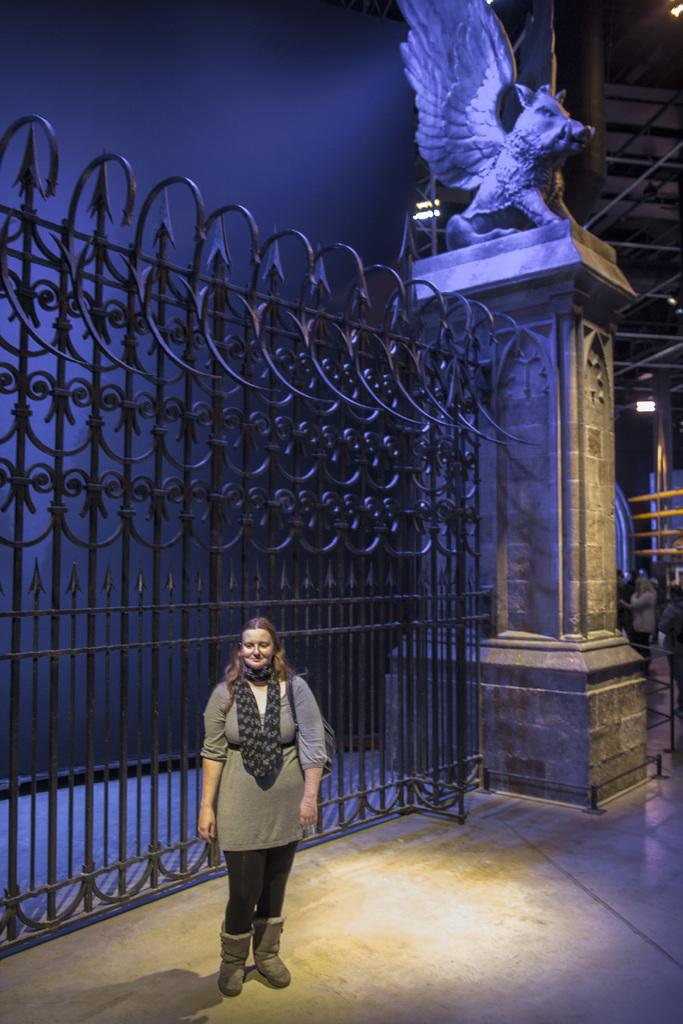What structure can be seen in the image? There is a gate in the image. What other object is present in the image? There is a statue in the image. Who is present in the image? There is a woman standing in the image. What is visible in the background of the image? The sky is visible in the image. What type of invention is being demonstrated by the woman in the image? There is no invention being demonstrated by the woman in the image; she is simply standing. What is the purpose of the cannon in the image? There is no cannon present in the image. 